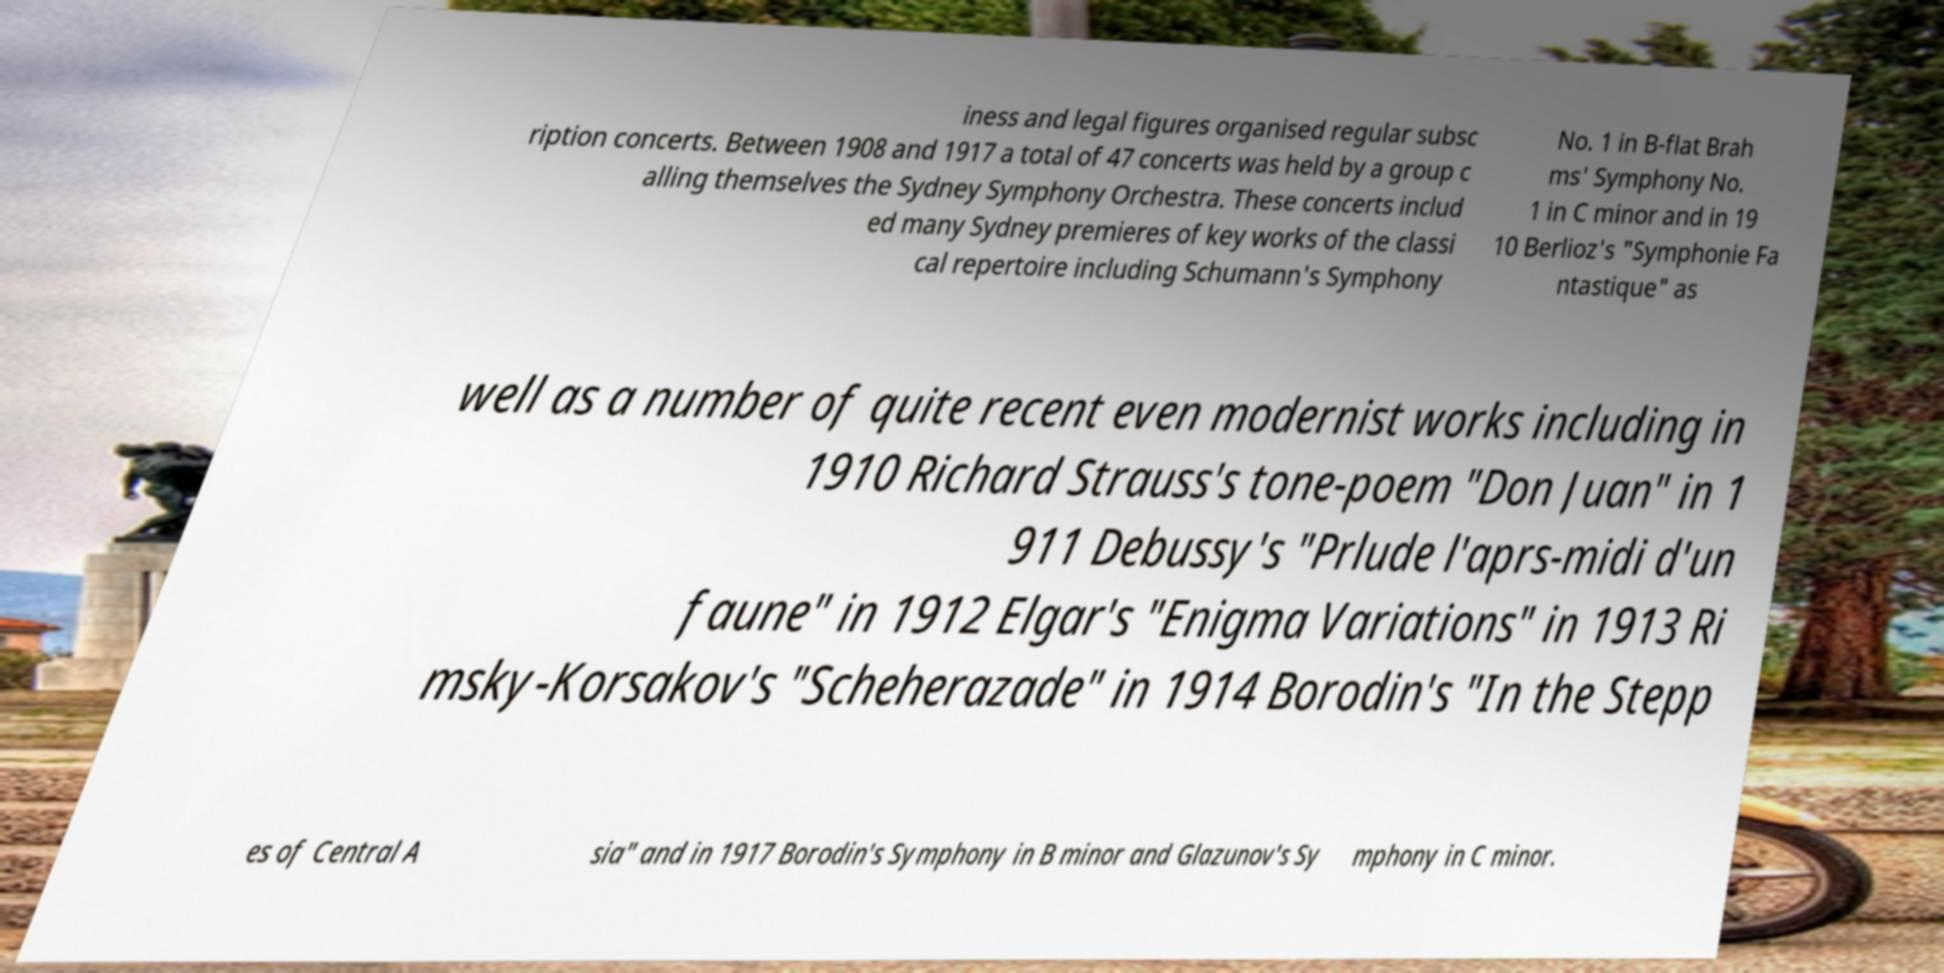What messages or text are displayed in this image? I need them in a readable, typed format. iness and legal figures organised regular subsc ription concerts. Between 1908 and 1917 a total of 47 concerts was held by a group c alling themselves the Sydney Symphony Orchestra. These concerts includ ed many Sydney premieres of key works of the classi cal repertoire including Schumann's Symphony No. 1 in B-flat Brah ms' Symphony No. 1 in C minor and in 19 10 Berlioz's "Symphonie Fa ntastique" as well as a number of quite recent even modernist works including in 1910 Richard Strauss's tone-poem "Don Juan" in 1 911 Debussy's "Prlude l'aprs-midi d'un faune" in 1912 Elgar's "Enigma Variations" in 1913 Ri msky-Korsakov's "Scheherazade" in 1914 Borodin's "In the Stepp es of Central A sia" and in 1917 Borodin's Symphony in B minor and Glazunov's Sy mphony in C minor. 